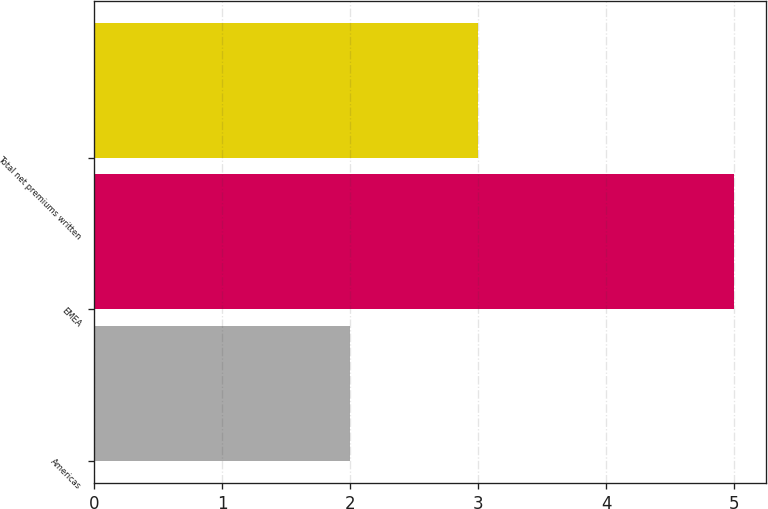Convert chart to OTSL. <chart><loc_0><loc_0><loc_500><loc_500><bar_chart><fcel>Americas<fcel>EMEA<fcel>Total net premiums written<nl><fcel>2<fcel>5<fcel>3<nl></chart> 